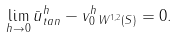<formula> <loc_0><loc_0><loc_500><loc_500>\lim _ { h \to 0 } \| \bar { u } ^ { h } _ { t a n } - v _ { 0 } ^ { h } \| _ { W ^ { 1 , 2 } ( S ) } = 0 .</formula> 